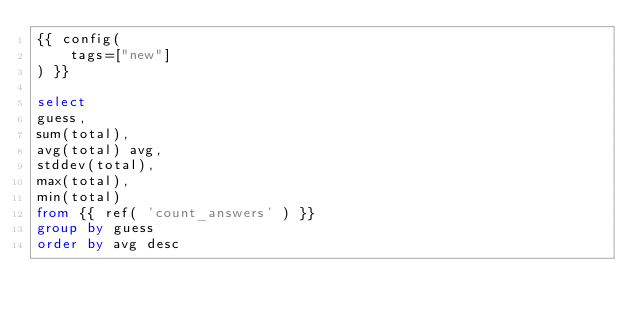Convert code to text. <code><loc_0><loc_0><loc_500><loc_500><_SQL_>{{ config(
    tags=["new"]
) }}

select
guess,
sum(total),
avg(total) avg,
stddev(total),
max(total),
min(total)
from {{ ref( 'count_answers' ) }}
group by guess
order by avg desc</code> 